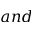<formula> <loc_0><loc_0><loc_500><loc_500>a n d</formula> 